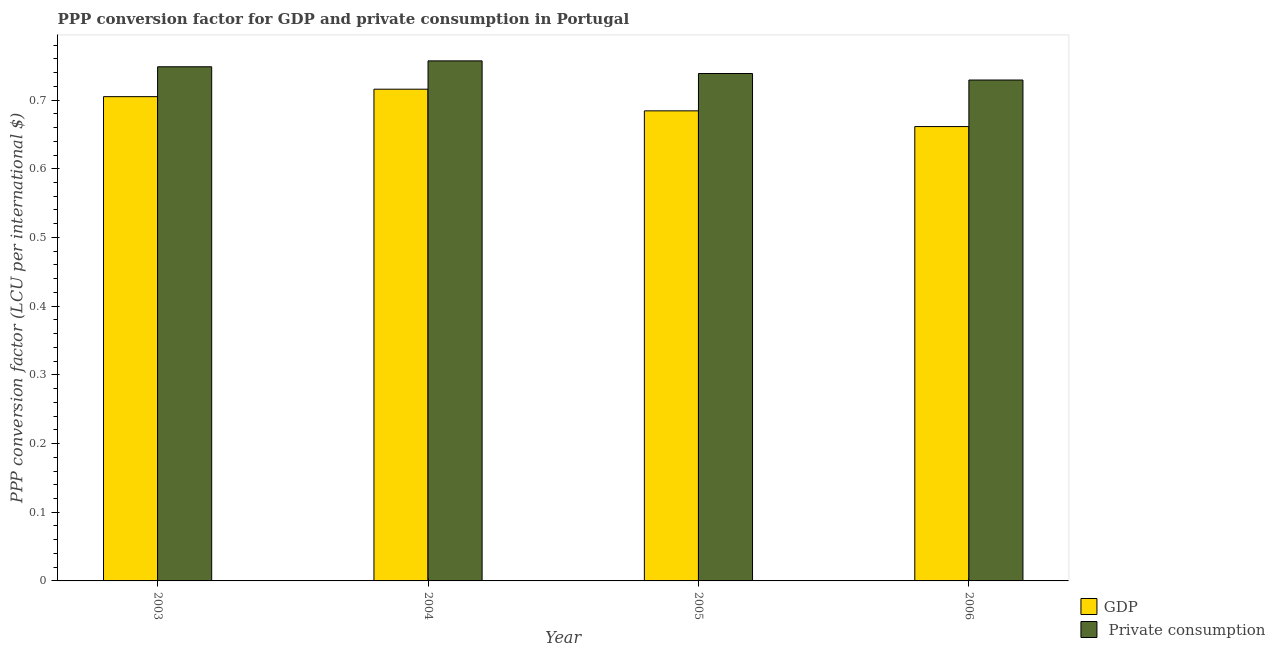How many groups of bars are there?
Provide a short and direct response. 4. How many bars are there on the 1st tick from the left?
Make the answer very short. 2. How many bars are there on the 3rd tick from the right?
Keep it short and to the point. 2. In how many cases, is the number of bars for a given year not equal to the number of legend labels?
Your response must be concise. 0. What is the ppp conversion factor for private consumption in 2005?
Keep it short and to the point. 0.74. Across all years, what is the maximum ppp conversion factor for private consumption?
Provide a succinct answer. 0.76. Across all years, what is the minimum ppp conversion factor for private consumption?
Your response must be concise. 0.73. In which year was the ppp conversion factor for gdp maximum?
Give a very brief answer. 2004. In which year was the ppp conversion factor for gdp minimum?
Ensure brevity in your answer.  2006. What is the total ppp conversion factor for gdp in the graph?
Give a very brief answer. 2.77. What is the difference between the ppp conversion factor for gdp in 2004 and that in 2005?
Provide a succinct answer. 0.03. What is the difference between the ppp conversion factor for private consumption in 2005 and the ppp conversion factor for gdp in 2004?
Ensure brevity in your answer.  -0.02. What is the average ppp conversion factor for private consumption per year?
Provide a short and direct response. 0.74. In how many years, is the ppp conversion factor for gdp greater than 0.44 LCU?
Make the answer very short. 4. What is the ratio of the ppp conversion factor for gdp in 2004 to that in 2006?
Your response must be concise. 1.08. What is the difference between the highest and the second highest ppp conversion factor for private consumption?
Your answer should be very brief. 0.01. What is the difference between the highest and the lowest ppp conversion factor for private consumption?
Your answer should be very brief. 0.03. Is the sum of the ppp conversion factor for gdp in 2003 and 2005 greater than the maximum ppp conversion factor for private consumption across all years?
Provide a succinct answer. Yes. What does the 1st bar from the left in 2006 represents?
Provide a short and direct response. GDP. What does the 2nd bar from the right in 2006 represents?
Provide a short and direct response. GDP. How many bars are there?
Keep it short and to the point. 8. What is the difference between two consecutive major ticks on the Y-axis?
Your answer should be very brief. 0.1. Does the graph contain grids?
Keep it short and to the point. No. How are the legend labels stacked?
Your answer should be very brief. Vertical. What is the title of the graph?
Make the answer very short. PPP conversion factor for GDP and private consumption in Portugal. Does "Study and work" appear as one of the legend labels in the graph?
Make the answer very short. No. What is the label or title of the X-axis?
Give a very brief answer. Year. What is the label or title of the Y-axis?
Keep it short and to the point. PPP conversion factor (LCU per international $). What is the PPP conversion factor (LCU per international $) in GDP in 2003?
Ensure brevity in your answer.  0.71. What is the PPP conversion factor (LCU per international $) of  Private consumption in 2003?
Give a very brief answer. 0.75. What is the PPP conversion factor (LCU per international $) in GDP in 2004?
Your answer should be compact. 0.72. What is the PPP conversion factor (LCU per international $) of  Private consumption in 2004?
Provide a succinct answer. 0.76. What is the PPP conversion factor (LCU per international $) in GDP in 2005?
Offer a terse response. 0.68. What is the PPP conversion factor (LCU per international $) in  Private consumption in 2005?
Give a very brief answer. 0.74. What is the PPP conversion factor (LCU per international $) of GDP in 2006?
Your answer should be very brief. 0.66. What is the PPP conversion factor (LCU per international $) in  Private consumption in 2006?
Provide a short and direct response. 0.73. Across all years, what is the maximum PPP conversion factor (LCU per international $) of GDP?
Your response must be concise. 0.72. Across all years, what is the maximum PPP conversion factor (LCU per international $) in  Private consumption?
Provide a short and direct response. 0.76. Across all years, what is the minimum PPP conversion factor (LCU per international $) in GDP?
Keep it short and to the point. 0.66. Across all years, what is the minimum PPP conversion factor (LCU per international $) in  Private consumption?
Keep it short and to the point. 0.73. What is the total PPP conversion factor (LCU per international $) in GDP in the graph?
Give a very brief answer. 2.77. What is the total PPP conversion factor (LCU per international $) in  Private consumption in the graph?
Your answer should be very brief. 2.97. What is the difference between the PPP conversion factor (LCU per international $) in GDP in 2003 and that in 2004?
Keep it short and to the point. -0.01. What is the difference between the PPP conversion factor (LCU per international $) of  Private consumption in 2003 and that in 2004?
Offer a terse response. -0.01. What is the difference between the PPP conversion factor (LCU per international $) of GDP in 2003 and that in 2005?
Offer a terse response. 0.02. What is the difference between the PPP conversion factor (LCU per international $) in  Private consumption in 2003 and that in 2005?
Your answer should be compact. 0.01. What is the difference between the PPP conversion factor (LCU per international $) in GDP in 2003 and that in 2006?
Your answer should be very brief. 0.04. What is the difference between the PPP conversion factor (LCU per international $) of  Private consumption in 2003 and that in 2006?
Make the answer very short. 0.02. What is the difference between the PPP conversion factor (LCU per international $) in GDP in 2004 and that in 2005?
Your response must be concise. 0.03. What is the difference between the PPP conversion factor (LCU per international $) in  Private consumption in 2004 and that in 2005?
Keep it short and to the point. 0.02. What is the difference between the PPP conversion factor (LCU per international $) in GDP in 2004 and that in 2006?
Provide a succinct answer. 0.05. What is the difference between the PPP conversion factor (LCU per international $) in  Private consumption in 2004 and that in 2006?
Your answer should be very brief. 0.03. What is the difference between the PPP conversion factor (LCU per international $) in GDP in 2005 and that in 2006?
Offer a terse response. 0.02. What is the difference between the PPP conversion factor (LCU per international $) of  Private consumption in 2005 and that in 2006?
Your answer should be compact. 0.01. What is the difference between the PPP conversion factor (LCU per international $) of GDP in 2003 and the PPP conversion factor (LCU per international $) of  Private consumption in 2004?
Offer a very short reply. -0.05. What is the difference between the PPP conversion factor (LCU per international $) in GDP in 2003 and the PPP conversion factor (LCU per international $) in  Private consumption in 2005?
Provide a succinct answer. -0.03. What is the difference between the PPP conversion factor (LCU per international $) of GDP in 2003 and the PPP conversion factor (LCU per international $) of  Private consumption in 2006?
Give a very brief answer. -0.02. What is the difference between the PPP conversion factor (LCU per international $) of GDP in 2004 and the PPP conversion factor (LCU per international $) of  Private consumption in 2005?
Offer a terse response. -0.02. What is the difference between the PPP conversion factor (LCU per international $) in GDP in 2004 and the PPP conversion factor (LCU per international $) in  Private consumption in 2006?
Your response must be concise. -0.01. What is the difference between the PPP conversion factor (LCU per international $) of GDP in 2005 and the PPP conversion factor (LCU per international $) of  Private consumption in 2006?
Your response must be concise. -0.04. What is the average PPP conversion factor (LCU per international $) of GDP per year?
Give a very brief answer. 0.69. What is the average PPP conversion factor (LCU per international $) of  Private consumption per year?
Your answer should be compact. 0.74. In the year 2003, what is the difference between the PPP conversion factor (LCU per international $) in GDP and PPP conversion factor (LCU per international $) in  Private consumption?
Give a very brief answer. -0.04. In the year 2004, what is the difference between the PPP conversion factor (LCU per international $) in GDP and PPP conversion factor (LCU per international $) in  Private consumption?
Your answer should be very brief. -0.04. In the year 2005, what is the difference between the PPP conversion factor (LCU per international $) in GDP and PPP conversion factor (LCU per international $) in  Private consumption?
Offer a terse response. -0.05. In the year 2006, what is the difference between the PPP conversion factor (LCU per international $) in GDP and PPP conversion factor (LCU per international $) in  Private consumption?
Keep it short and to the point. -0.07. What is the ratio of the PPP conversion factor (LCU per international $) in GDP in 2003 to that in 2004?
Your answer should be very brief. 0.98. What is the ratio of the PPP conversion factor (LCU per international $) in  Private consumption in 2003 to that in 2004?
Make the answer very short. 0.99. What is the ratio of the PPP conversion factor (LCU per international $) of GDP in 2003 to that in 2005?
Provide a succinct answer. 1.03. What is the ratio of the PPP conversion factor (LCU per international $) of  Private consumption in 2003 to that in 2005?
Ensure brevity in your answer.  1.01. What is the ratio of the PPP conversion factor (LCU per international $) of GDP in 2003 to that in 2006?
Ensure brevity in your answer.  1.07. What is the ratio of the PPP conversion factor (LCU per international $) of  Private consumption in 2003 to that in 2006?
Ensure brevity in your answer.  1.03. What is the ratio of the PPP conversion factor (LCU per international $) of GDP in 2004 to that in 2005?
Keep it short and to the point. 1.05. What is the ratio of the PPP conversion factor (LCU per international $) in  Private consumption in 2004 to that in 2005?
Ensure brevity in your answer.  1.02. What is the ratio of the PPP conversion factor (LCU per international $) in GDP in 2004 to that in 2006?
Ensure brevity in your answer.  1.08. What is the ratio of the PPP conversion factor (LCU per international $) of  Private consumption in 2004 to that in 2006?
Make the answer very short. 1.04. What is the ratio of the PPP conversion factor (LCU per international $) in GDP in 2005 to that in 2006?
Make the answer very short. 1.03. What is the ratio of the PPP conversion factor (LCU per international $) of  Private consumption in 2005 to that in 2006?
Give a very brief answer. 1.01. What is the difference between the highest and the second highest PPP conversion factor (LCU per international $) in GDP?
Your response must be concise. 0.01. What is the difference between the highest and the second highest PPP conversion factor (LCU per international $) in  Private consumption?
Provide a succinct answer. 0.01. What is the difference between the highest and the lowest PPP conversion factor (LCU per international $) of GDP?
Give a very brief answer. 0.05. What is the difference between the highest and the lowest PPP conversion factor (LCU per international $) of  Private consumption?
Ensure brevity in your answer.  0.03. 